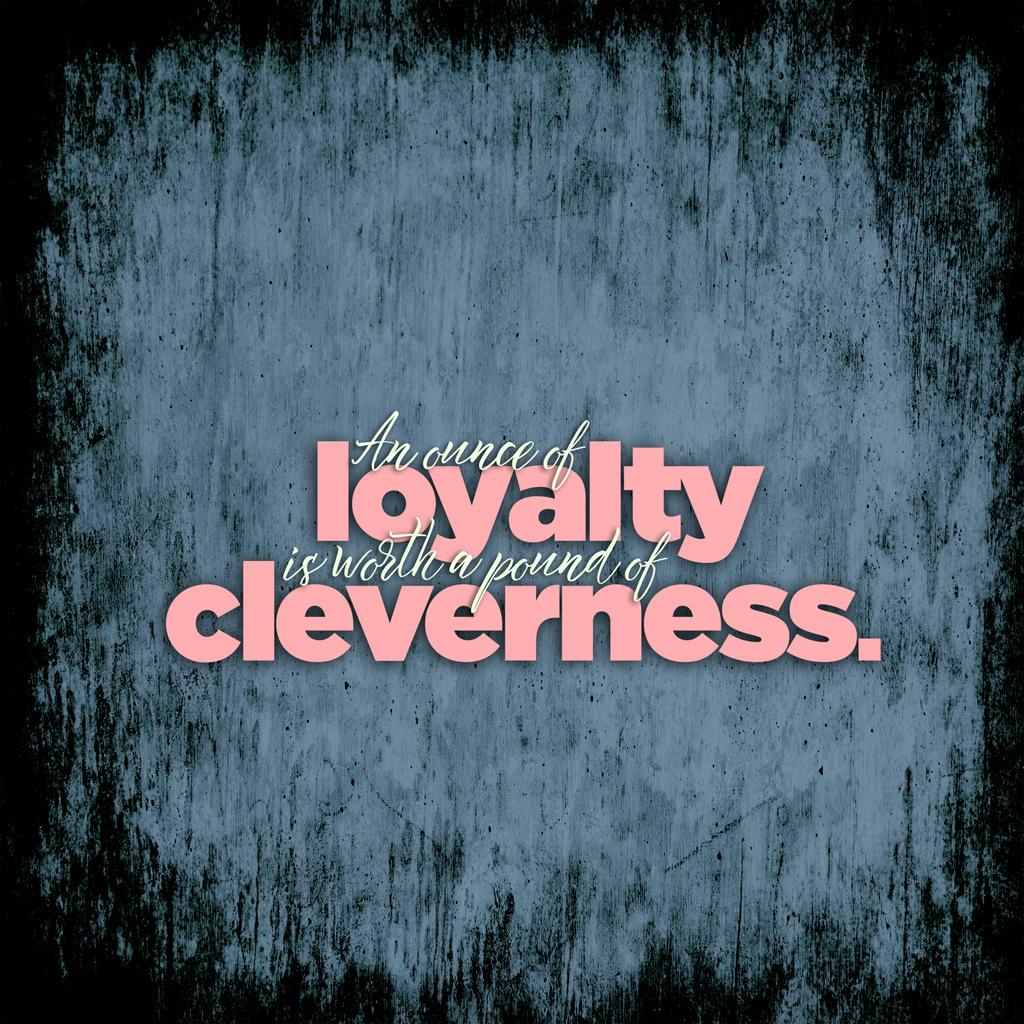<image>
Offer a succinct explanation of the picture presented. an image with the text which says "An ounce of loyalty is worth a pound of cleverness.". 